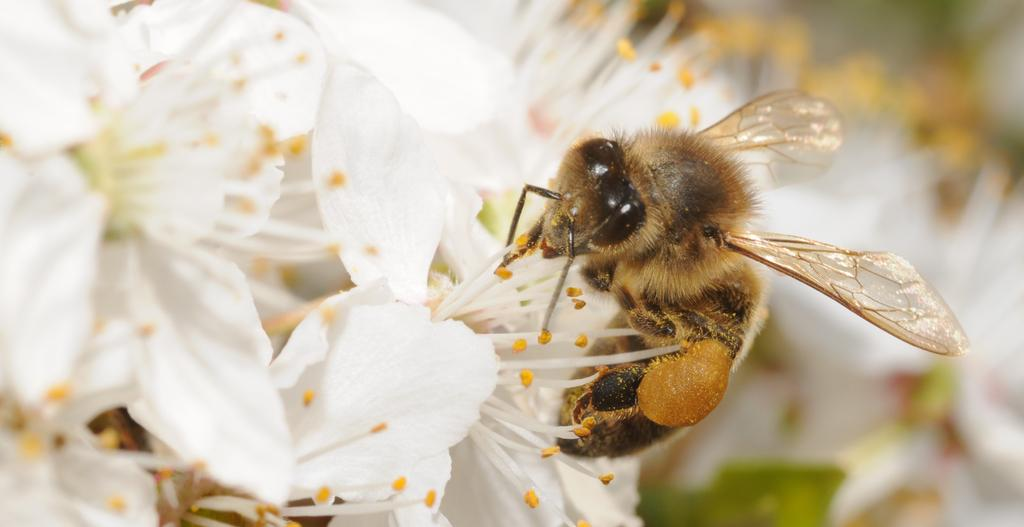What type of insect is present in the image? There is a honey bee in the image. Where is the honey bee located in the image? The honey bee is on the flowers. What type of button can be seen on the hen in the image? There is no hen or button present in the image; it only features a honey bee on the flowers. 